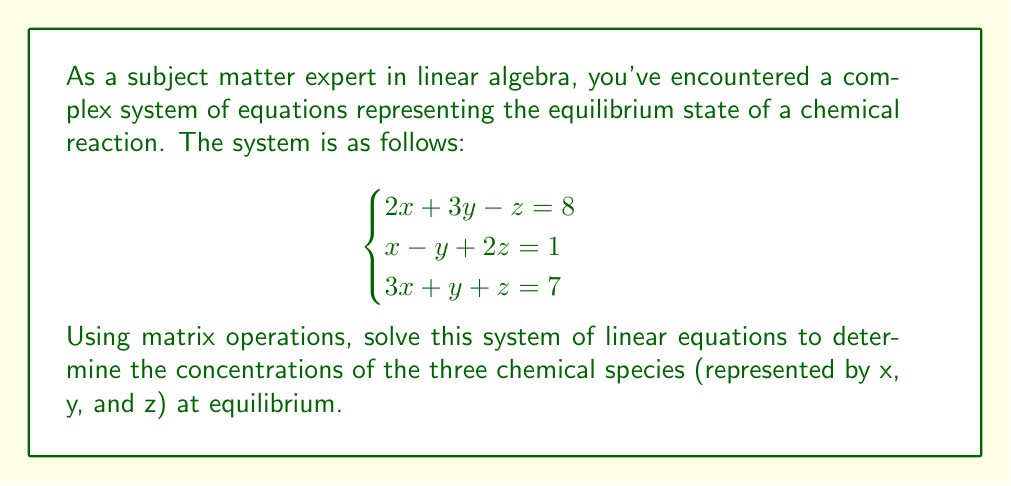Show me your answer to this math problem. To solve this system using matrix operations, we'll follow these steps:

1) First, let's express the system in matrix form:

   $$\begin{bmatrix}
   2 & 3 & -1 \\
   1 & -1 & 2 \\
   3 & 1 & 1
   \end{bmatrix}
   \begin{bmatrix}
   x \\
   y \\
   z
   \end{bmatrix} =
   \begin{bmatrix}
   8 \\
   1 \\
   7
   \end{bmatrix}$$

   Let's call the coefficient matrix A, the variable matrix X, and the constant matrix B.

2) To solve for X, we need to find $A^{-1}$ and then multiply both sides by it:

   $A^{-1}AX = A^{-1}B$

3) To find $A^{-1}$, we'll use the adjugate method:

   First, calculate the determinant of A:
   $det(A) = 2(-1-2) + 3(2-3) + (-1)(1-9) = -4 - 3 + 8 = 1$

   Now, find the adjugate matrix:
   $$adj(A) = \begin{bmatrix}
   (-1-2) & -(3-3) & (3+1) \\
   -(2-9) & (2-3) & -(2+3) \\
   (1+6) & -(1-6) & (2-3)
   \end{bmatrix} = 
   \begin{bmatrix}
   -3 & 0 & 4 \\
   7 & -1 & -5 \\
   7 & 5 & -1
   \end{bmatrix}$$

   $A^{-1} = \frac{1}{det(A)} adj(A) = adj(A)$ (since $det(A) = 1$)

4) Now we can solve for X:

   $$X = A^{-1}B = 
   \begin{bmatrix}
   -3 & 0 & 4 \\
   7 & -1 & -5 \\
   7 & 5 & -1
   \end{bmatrix}
   \begin{bmatrix}
   8 \\
   1 \\
   7
   \end{bmatrix}$$

5) Performing the matrix multiplication:

   $$X = \begin{bmatrix}
   (-3)(8) + (0)(1) + (4)(7) \\
   (7)(8) + (-1)(1) + (-5)(7) \\
   (7)(8) + (5)(1) + (-1)(7)
   \end{bmatrix} = 
   \begin{bmatrix}
   4 \\
   20 \\
   56
   \end{bmatrix}$$

6) Dividing by the common factor 4:

   $$X = \begin{bmatrix}
   1 \\
   5 \\
   14
   \end{bmatrix}$$

Therefore, $x = 1$, $y = 5$, and $z = 14$.
Answer: The solution to the system of equations is $x = 1$, $y = 5$, and $z = 14$. 